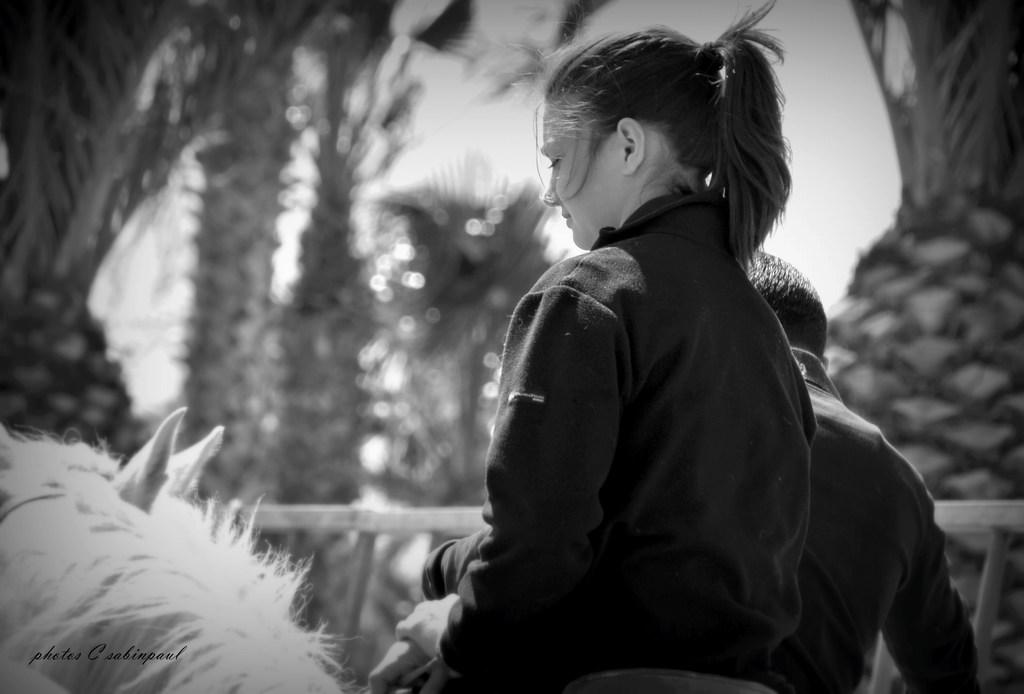How many people are in the image? There is a woman and a man in the image, making a total of two people. What other living beings are present in the image? There are two animals in the image. Can you describe the vegetation in the image? There are trees on the top right, bottom, and also scattered throughout the image. What type of crack can be seen in the image? There is no crack present in the image. What route are the people taking in the image? The image does not show any specific route or direction the people are taking. 